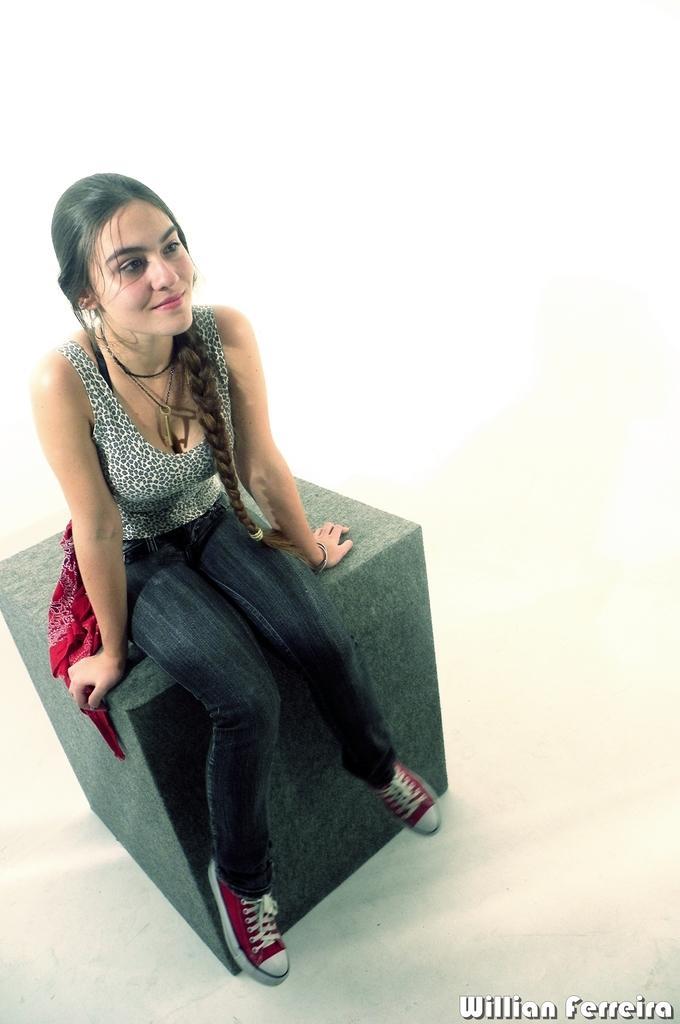How would you summarize this image in a sentence or two? In this image I can see the person sitting on the gray color surface and the person is wearing black and white color dress and I can see the white color background. 